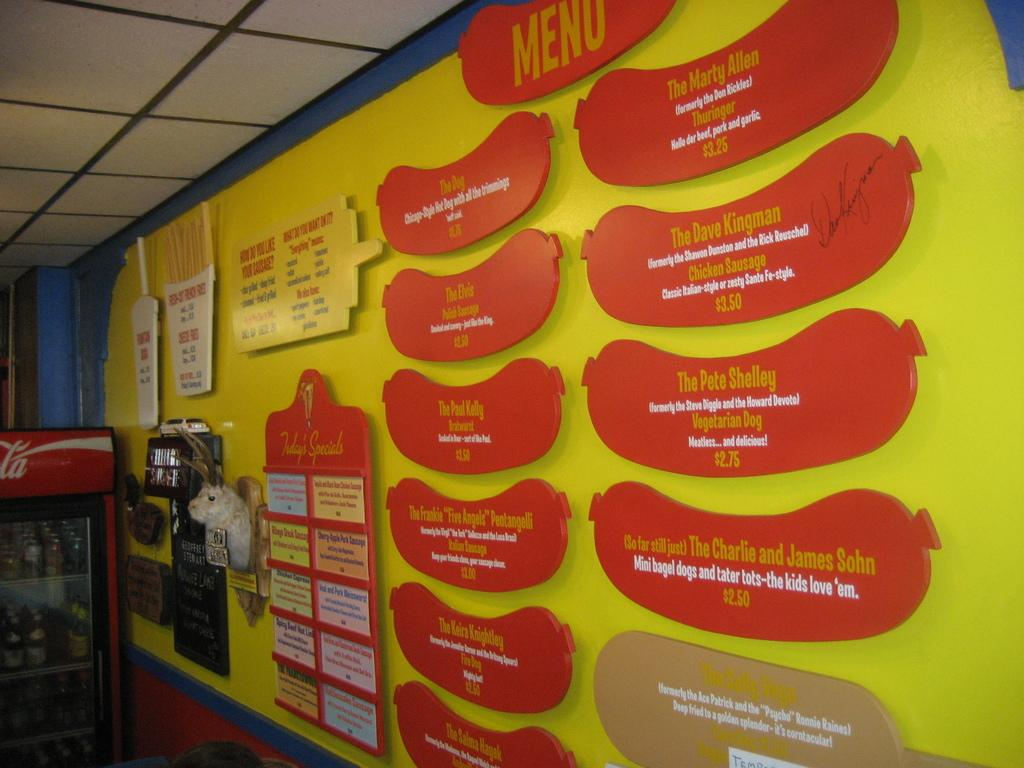<image>
Provide a brief description of the given image. a menu of a restaurant on a yellow wall including a vegetarian dog for 2.75 